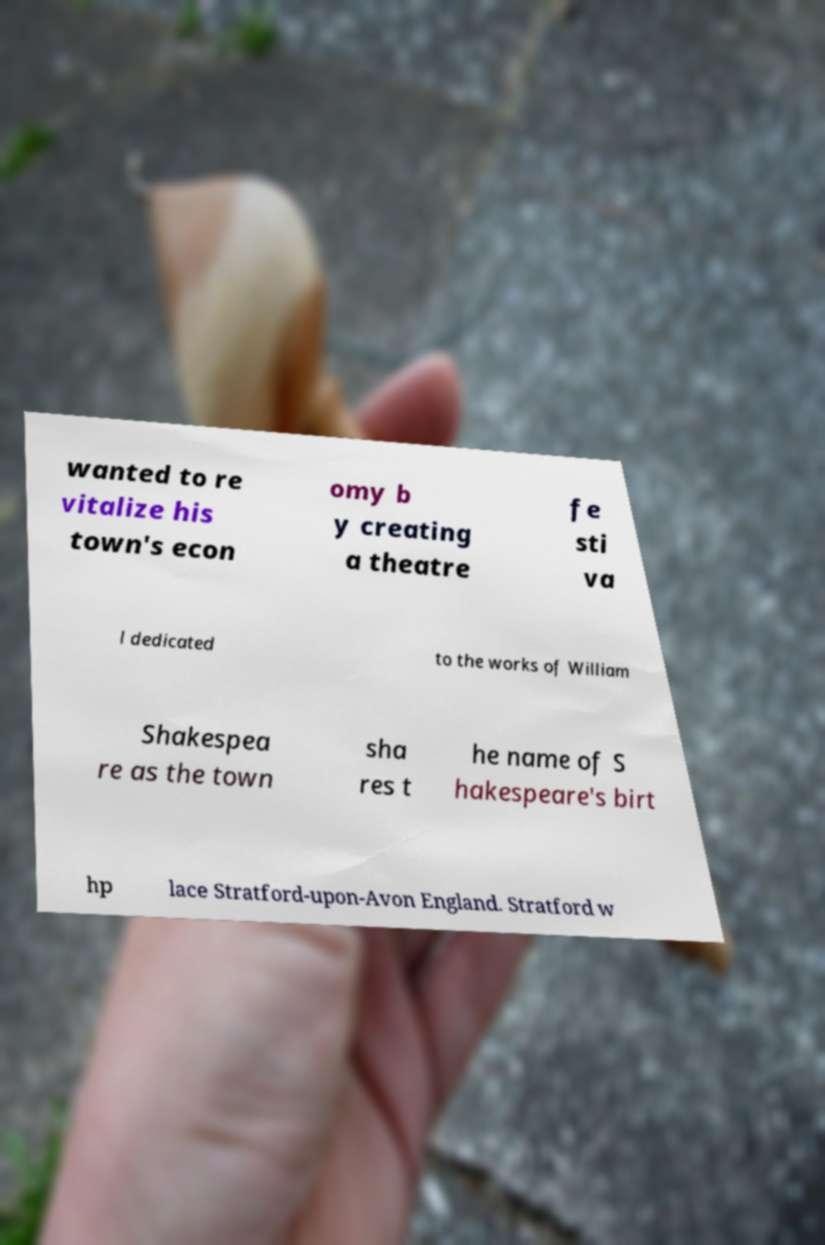Could you extract and type out the text from this image? wanted to re vitalize his town's econ omy b y creating a theatre fe sti va l dedicated to the works of William Shakespea re as the town sha res t he name of S hakespeare's birt hp lace Stratford-upon-Avon England. Stratford w 